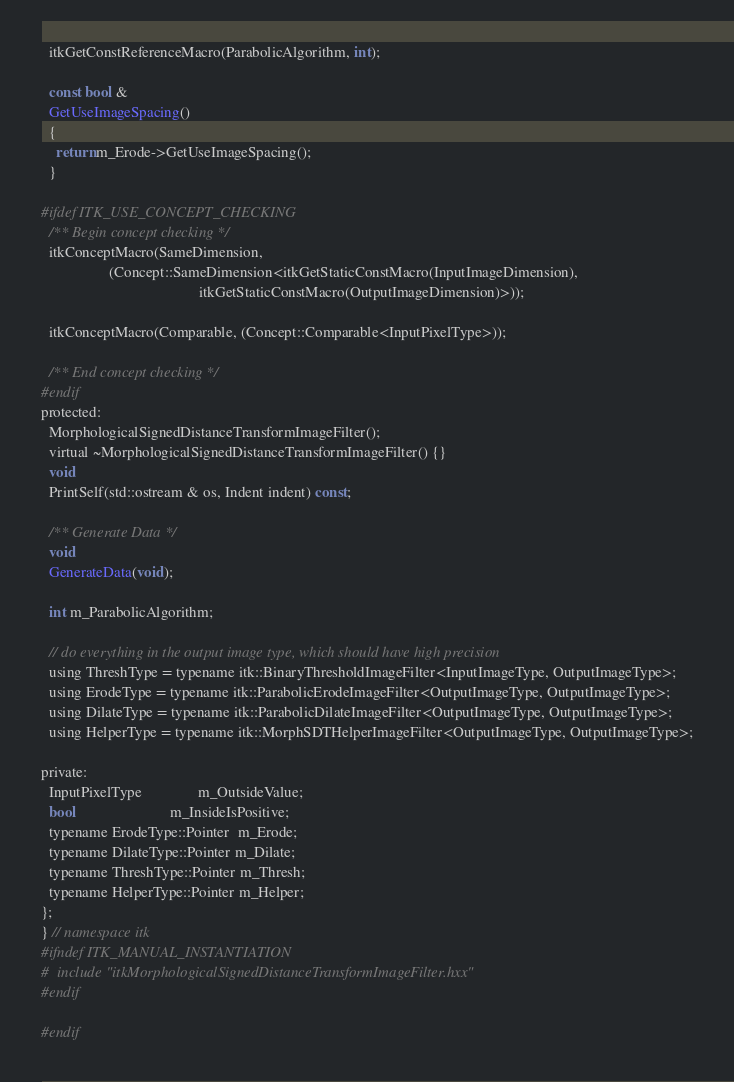<code> <loc_0><loc_0><loc_500><loc_500><_C_>  itkGetConstReferenceMacro(ParabolicAlgorithm, int);

  const bool &
  GetUseImageSpacing()
  {
    return m_Erode->GetUseImageSpacing();
  }

#ifdef ITK_USE_CONCEPT_CHECKING
  /** Begin concept checking */
  itkConceptMacro(SameDimension,
                  (Concept::SameDimension<itkGetStaticConstMacro(InputImageDimension),
                                          itkGetStaticConstMacro(OutputImageDimension)>));

  itkConceptMacro(Comparable, (Concept::Comparable<InputPixelType>));

  /** End concept checking */
#endif
protected:
  MorphologicalSignedDistanceTransformImageFilter();
  virtual ~MorphologicalSignedDistanceTransformImageFilter() {}
  void
  PrintSelf(std::ostream & os, Indent indent) const;

  /** Generate Data */
  void
  GenerateData(void);

  int m_ParabolicAlgorithm;

  // do everything in the output image type, which should have high precision
  using ThreshType = typename itk::BinaryThresholdImageFilter<InputImageType, OutputImageType>;
  using ErodeType = typename itk::ParabolicErodeImageFilter<OutputImageType, OutputImageType>;
  using DilateType = typename itk::ParabolicDilateImageFilter<OutputImageType, OutputImageType>;
  using HelperType = typename itk::MorphSDTHelperImageFilter<OutputImageType, OutputImageType>;

private:
  InputPixelType               m_OutsideValue;
  bool                         m_InsideIsPositive;
  typename ErodeType::Pointer  m_Erode;
  typename DilateType::Pointer m_Dilate;
  typename ThreshType::Pointer m_Thresh;
  typename HelperType::Pointer m_Helper;
};
} // namespace itk
#ifndef ITK_MANUAL_INSTANTIATION
#  include "itkMorphologicalSignedDistanceTransformImageFilter.hxx"
#endif

#endif
</code> 